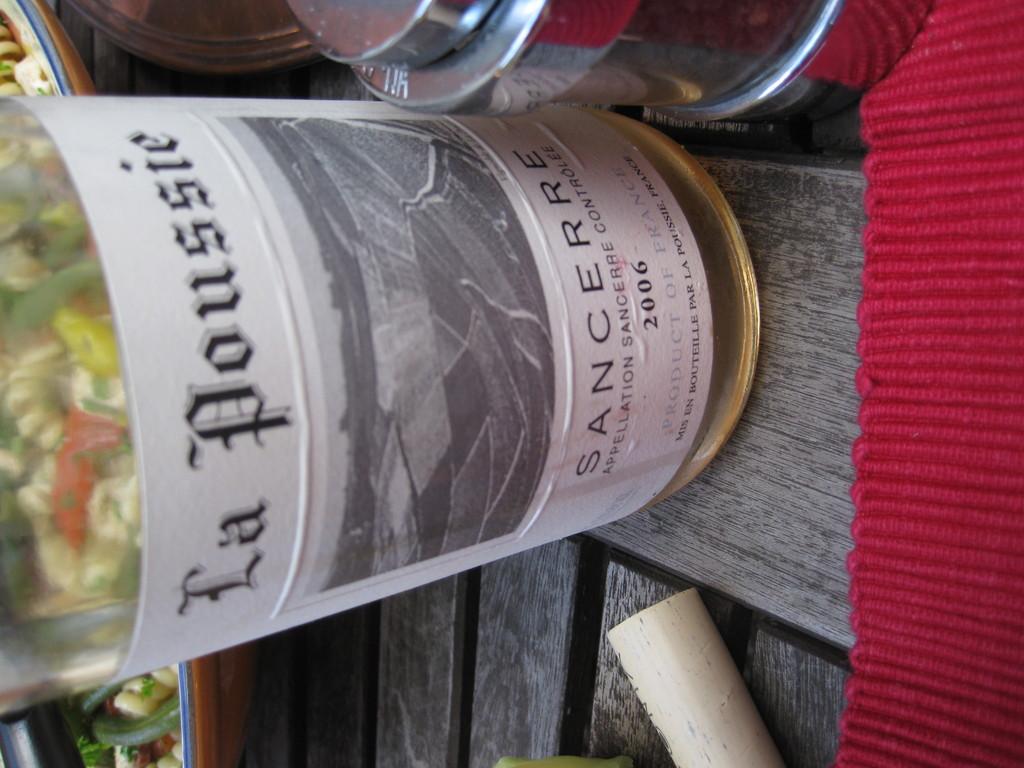This wine was bottled in what year?
Provide a succinct answer. 2006. What is the maker of the wine?
Provide a short and direct response. La poussie. 